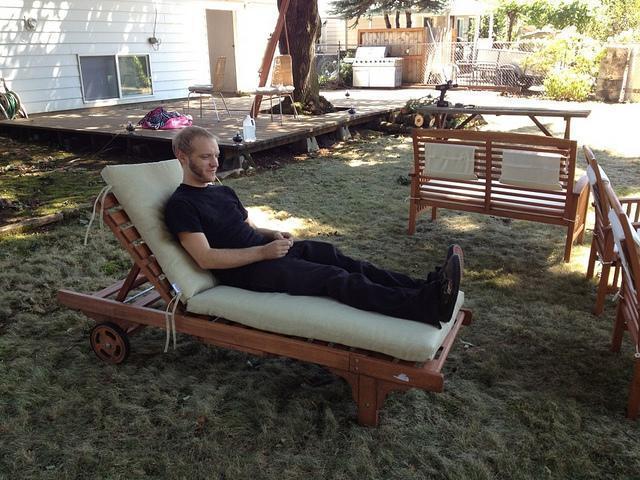How many people are in the picture?
Give a very brief answer. 2. How many benches are visible?
Give a very brief answer. 2. How many chairs are there?
Give a very brief answer. 1. 